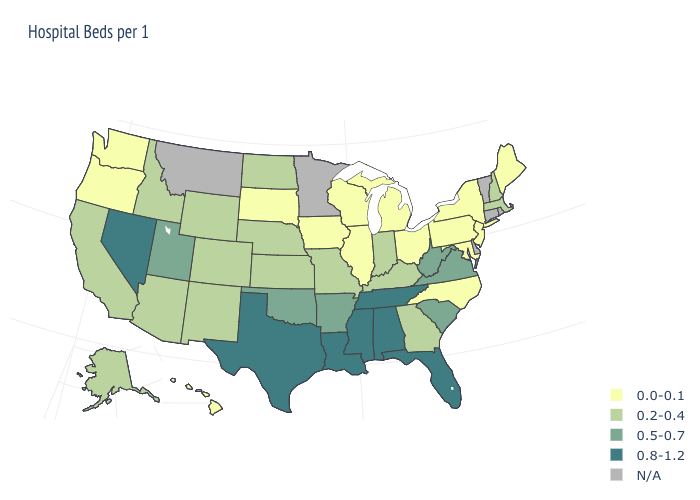What is the value of Arizona?
Concise answer only. 0.2-0.4. What is the value of Wyoming?
Concise answer only. 0.2-0.4. How many symbols are there in the legend?
Keep it brief. 5. Among the states that border Tennessee , does Missouri have the lowest value?
Be succinct. No. What is the value of Connecticut?
Concise answer only. N/A. Name the states that have a value in the range 0.8-1.2?
Quick response, please. Alabama, Florida, Louisiana, Mississippi, Nevada, Tennessee, Texas. Among the states that border Georgia , does Alabama have the highest value?
Keep it brief. Yes. Does New Jersey have the highest value in the Northeast?
Concise answer only. No. Is the legend a continuous bar?
Be succinct. No. Does the map have missing data?
Be succinct. Yes. Does Maryland have the lowest value in the South?
Quick response, please. Yes. Name the states that have a value in the range 0.2-0.4?
Be succinct. Alaska, Arizona, California, Colorado, Georgia, Idaho, Indiana, Kansas, Kentucky, Massachusetts, Missouri, Nebraska, New Hampshire, New Mexico, North Dakota, Wyoming. Name the states that have a value in the range 0.0-0.1?
Be succinct. Hawaii, Illinois, Iowa, Maine, Maryland, Michigan, New Jersey, New York, North Carolina, Ohio, Oregon, Pennsylvania, South Dakota, Washington, Wisconsin. What is the highest value in the Northeast ?
Short answer required. 0.2-0.4. 